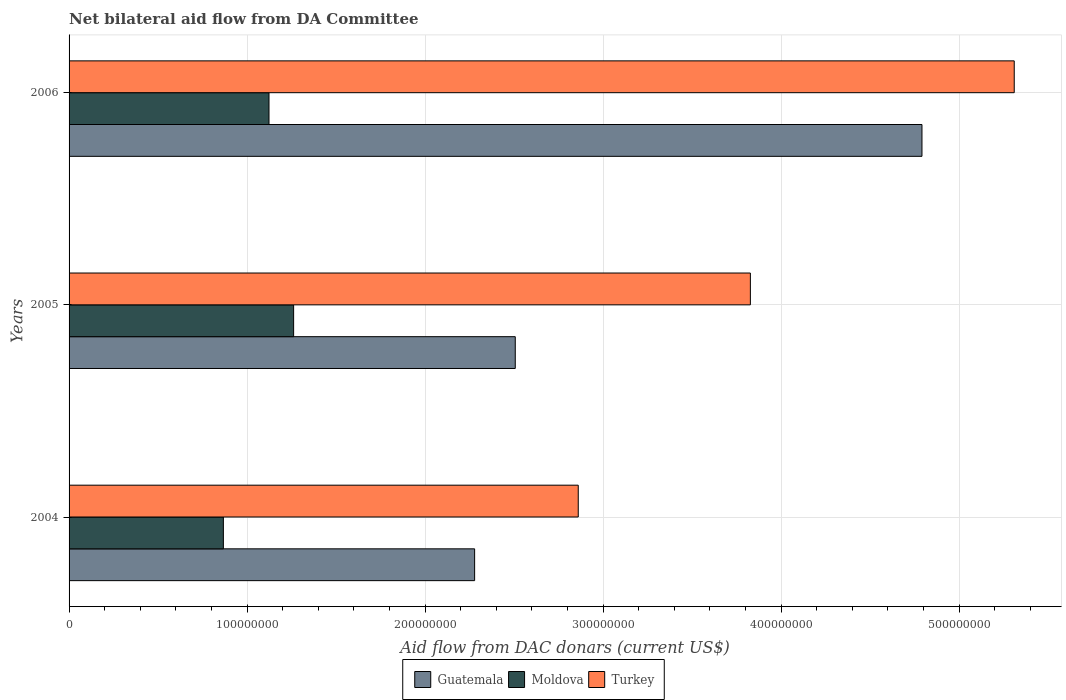How many different coloured bars are there?
Provide a short and direct response. 3. How many groups of bars are there?
Your answer should be compact. 3. How many bars are there on the 2nd tick from the bottom?
Give a very brief answer. 3. In how many cases, is the number of bars for a given year not equal to the number of legend labels?
Offer a terse response. 0. What is the aid flow in in Guatemala in 2004?
Ensure brevity in your answer.  2.28e+08. Across all years, what is the maximum aid flow in in Turkey?
Keep it short and to the point. 5.31e+08. Across all years, what is the minimum aid flow in in Turkey?
Ensure brevity in your answer.  2.86e+08. In which year was the aid flow in in Moldova maximum?
Give a very brief answer. 2005. What is the total aid flow in in Turkey in the graph?
Keep it short and to the point. 1.20e+09. What is the difference between the aid flow in in Guatemala in 2004 and that in 2006?
Keep it short and to the point. -2.51e+08. What is the difference between the aid flow in in Turkey in 2006 and the aid flow in in Guatemala in 2005?
Ensure brevity in your answer.  2.80e+08. What is the average aid flow in in Guatemala per year?
Your answer should be compact. 3.19e+08. In the year 2004, what is the difference between the aid flow in in Guatemala and aid flow in in Turkey?
Provide a succinct answer. -5.82e+07. In how many years, is the aid flow in in Moldova greater than 500000000 US$?
Make the answer very short. 0. What is the ratio of the aid flow in in Turkey in 2004 to that in 2006?
Your answer should be very brief. 0.54. Is the difference between the aid flow in in Guatemala in 2004 and 2006 greater than the difference between the aid flow in in Turkey in 2004 and 2006?
Provide a succinct answer. No. What is the difference between the highest and the second highest aid flow in in Turkey?
Give a very brief answer. 1.48e+08. What is the difference between the highest and the lowest aid flow in in Turkey?
Provide a short and direct response. 2.45e+08. What does the 1st bar from the top in 2006 represents?
Your response must be concise. Turkey. What does the 3rd bar from the bottom in 2006 represents?
Your response must be concise. Turkey. How many bars are there?
Keep it short and to the point. 9. Are the values on the major ticks of X-axis written in scientific E-notation?
Your answer should be very brief. No. Does the graph contain any zero values?
Provide a short and direct response. No. Does the graph contain grids?
Offer a very short reply. Yes. Where does the legend appear in the graph?
Provide a short and direct response. Bottom center. How many legend labels are there?
Your response must be concise. 3. How are the legend labels stacked?
Your answer should be very brief. Horizontal. What is the title of the graph?
Offer a very short reply. Net bilateral aid flow from DA Committee. Does "Kazakhstan" appear as one of the legend labels in the graph?
Your answer should be compact. No. What is the label or title of the X-axis?
Offer a terse response. Aid flow from DAC donars (current US$). What is the label or title of the Y-axis?
Offer a terse response. Years. What is the Aid flow from DAC donars (current US$) in Guatemala in 2004?
Keep it short and to the point. 2.28e+08. What is the Aid flow from DAC donars (current US$) of Moldova in 2004?
Make the answer very short. 8.67e+07. What is the Aid flow from DAC donars (current US$) of Turkey in 2004?
Provide a short and direct response. 2.86e+08. What is the Aid flow from DAC donars (current US$) of Guatemala in 2005?
Keep it short and to the point. 2.51e+08. What is the Aid flow from DAC donars (current US$) of Moldova in 2005?
Your answer should be very brief. 1.26e+08. What is the Aid flow from DAC donars (current US$) of Turkey in 2005?
Give a very brief answer. 3.83e+08. What is the Aid flow from DAC donars (current US$) in Guatemala in 2006?
Keep it short and to the point. 4.79e+08. What is the Aid flow from DAC donars (current US$) of Moldova in 2006?
Ensure brevity in your answer.  1.12e+08. What is the Aid flow from DAC donars (current US$) of Turkey in 2006?
Give a very brief answer. 5.31e+08. Across all years, what is the maximum Aid flow from DAC donars (current US$) in Guatemala?
Ensure brevity in your answer.  4.79e+08. Across all years, what is the maximum Aid flow from DAC donars (current US$) in Moldova?
Your answer should be very brief. 1.26e+08. Across all years, what is the maximum Aid flow from DAC donars (current US$) in Turkey?
Provide a short and direct response. 5.31e+08. Across all years, what is the minimum Aid flow from DAC donars (current US$) of Guatemala?
Give a very brief answer. 2.28e+08. Across all years, what is the minimum Aid flow from DAC donars (current US$) in Moldova?
Offer a very short reply. 8.67e+07. Across all years, what is the minimum Aid flow from DAC donars (current US$) in Turkey?
Keep it short and to the point. 2.86e+08. What is the total Aid flow from DAC donars (current US$) in Guatemala in the graph?
Offer a very short reply. 9.58e+08. What is the total Aid flow from DAC donars (current US$) of Moldova in the graph?
Provide a short and direct response. 3.25e+08. What is the total Aid flow from DAC donars (current US$) of Turkey in the graph?
Offer a very short reply. 1.20e+09. What is the difference between the Aid flow from DAC donars (current US$) of Guatemala in 2004 and that in 2005?
Your answer should be very brief. -2.28e+07. What is the difference between the Aid flow from DAC donars (current US$) of Moldova in 2004 and that in 2005?
Provide a short and direct response. -3.95e+07. What is the difference between the Aid flow from DAC donars (current US$) of Turkey in 2004 and that in 2005?
Your response must be concise. -9.67e+07. What is the difference between the Aid flow from DAC donars (current US$) in Guatemala in 2004 and that in 2006?
Offer a very short reply. -2.51e+08. What is the difference between the Aid flow from DAC donars (current US$) in Moldova in 2004 and that in 2006?
Your answer should be very brief. -2.56e+07. What is the difference between the Aid flow from DAC donars (current US$) of Turkey in 2004 and that in 2006?
Offer a very short reply. -2.45e+08. What is the difference between the Aid flow from DAC donars (current US$) in Guatemala in 2005 and that in 2006?
Your answer should be compact. -2.28e+08. What is the difference between the Aid flow from DAC donars (current US$) of Moldova in 2005 and that in 2006?
Provide a succinct answer. 1.38e+07. What is the difference between the Aid flow from DAC donars (current US$) of Turkey in 2005 and that in 2006?
Offer a terse response. -1.48e+08. What is the difference between the Aid flow from DAC donars (current US$) in Guatemala in 2004 and the Aid flow from DAC donars (current US$) in Moldova in 2005?
Offer a very short reply. 1.02e+08. What is the difference between the Aid flow from DAC donars (current US$) in Guatemala in 2004 and the Aid flow from DAC donars (current US$) in Turkey in 2005?
Your answer should be compact. -1.55e+08. What is the difference between the Aid flow from DAC donars (current US$) of Moldova in 2004 and the Aid flow from DAC donars (current US$) of Turkey in 2005?
Your answer should be very brief. -2.96e+08. What is the difference between the Aid flow from DAC donars (current US$) in Guatemala in 2004 and the Aid flow from DAC donars (current US$) in Moldova in 2006?
Your answer should be compact. 1.16e+08. What is the difference between the Aid flow from DAC donars (current US$) of Guatemala in 2004 and the Aid flow from DAC donars (current US$) of Turkey in 2006?
Your response must be concise. -3.03e+08. What is the difference between the Aid flow from DAC donars (current US$) in Moldova in 2004 and the Aid flow from DAC donars (current US$) in Turkey in 2006?
Provide a succinct answer. -4.44e+08. What is the difference between the Aid flow from DAC donars (current US$) of Guatemala in 2005 and the Aid flow from DAC donars (current US$) of Moldova in 2006?
Provide a short and direct response. 1.38e+08. What is the difference between the Aid flow from DAC donars (current US$) of Guatemala in 2005 and the Aid flow from DAC donars (current US$) of Turkey in 2006?
Your response must be concise. -2.80e+08. What is the difference between the Aid flow from DAC donars (current US$) of Moldova in 2005 and the Aid flow from DAC donars (current US$) of Turkey in 2006?
Your response must be concise. -4.05e+08. What is the average Aid flow from DAC donars (current US$) in Guatemala per year?
Offer a very short reply. 3.19e+08. What is the average Aid flow from DAC donars (current US$) in Moldova per year?
Give a very brief answer. 1.08e+08. What is the average Aid flow from DAC donars (current US$) of Turkey per year?
Provide a short and direct response. 4.00e+08. In the year 2004, what is the difference between the Aid flow from DAC donars (current US$) of Guatemala and Aid flow from DAC donars (current US$) of Moldova?
Your answer should be very brief. 1.41e+08. In the year 2004, what is the difference between the Aid flow from DAC donars (current US$) in Guatemala and Aid flow from DAC donars (current US$) in Turkey?
Ensure brevity in your answer.  -5.82e+07. In the year 2004, what is the difference between the Aid flow from DAC donars (current US$) in Moldova and Aid flow from DAC donars (current US$) in Turkey?
Offer a terse response. -1.99e+08. In the year 2005, what is the difference between the Aid flow from DAC donars (current US$) of Guatemala and Aid flow from DAC donars (current US$) of Moldova?
Your response must be concise. 1.25e+08. In the year 2005, what is the difference between the Aid flow from DAC donars (current US$) of Guatemala and Aid flow from DAC donars (current US$) of Turkey?
Provide a succinct answer. -1.32e+08. In the year 2005, what is the difference between the Aid flow from DAC donars (current US$) of Moldova and Aid flow from DAC donars (current US$) of Turkey?
Your response must be concise. -2.57e+08. In the year 2006, what is the difference between the Aid flow from DAC donars (current US$) in Guatemala and Aid flow from DAC donars (current US$) in Moldova?
Make the answer very short. 3.67e+08. In the year 2006, what is the difference between the Aid flow from DAC donars (current US$) in Guatemala and Aid flow from DAC donars (current US$) in Turkey?
Your answer should be very brief. -5.18e+07. In the year 2006, what is the difference between the Aid flow from DAC donars (current US$) in Moldova and Aid flow from DAC donars (current US$) in Turkey?
Make the answer very short. -4.19e+08. What is the ratio of the Aid flow from DAC donars (current US$) in Guatemala in 2004 to that in 2005?
Keep it short and to the point. 0.91. What is the ratio of the Aid flow from DAC donars (current US$) of Moldova in 2004 to that in 2005?
Offer a terse response. 0.69. What is the ratio of the Aid flow from DAC donars (current US$) in Turkey in 2004 to that in 2005?
Your answer should be compact. 0.75. What is the ratio of the Aid flow from DAC donars (current US$) of Guatemala in 2004 to that in 2006?
Give a very brief answer. 0.48. What is the ratio of the Aid flow from DAC donars (current US$) in Moldova in 2004 to that in 2006?
Ensure brevity in your answer.  0.77. What is the ratio of the Aid flow from DAC donars (current US$) in Turkey in 2004 to that in 2006?
Give a very brief answer. 0.54. What is the ratio of the Aid flow from DAC donars (current US$) of Guatemala in 2005 to that in 2006?
Offer a very short reply. 0.52. What is the ratio of the Aid flow from DAC donars (current US$) of Moldova in 2005 to that in 2006?
Provide a succinct answer. 1.12. What is the ratio of the Aid flow from DAC donars (current US$) of Turkey in 2005 to that in 2006?
Your response must be concise. 0.72. What is the difference between the highest and the second highest Aid flow from DAC donars (current US$) of Guatemala?
Offer a terse response. 2.28e+08. What is the difference between the highest and the second highest Aid flow from DAC donars (current US$) in Moldova?
Offer a terse response. 1.38e+07. What is the difference between the highest and the second highest Aid flow from DAC donars (current US$) in Turkey?
Your answer should be compact. 1.48e+08. What is the difference between the highest and the lowest Aid flow from DAC donars (current US$) of Guatemala?
Offer a terse response. 2.51e+08. What is the difference between the highest and the lowest Aid flow from DAC donars (current US$) in Moldova?
Offer a very short reply. 3.95e+07. What is the difference between the highest and the lowest Aid flow from DAC donars (current US$) of Turkey?
Make the answer very short. 2.45e+08. 